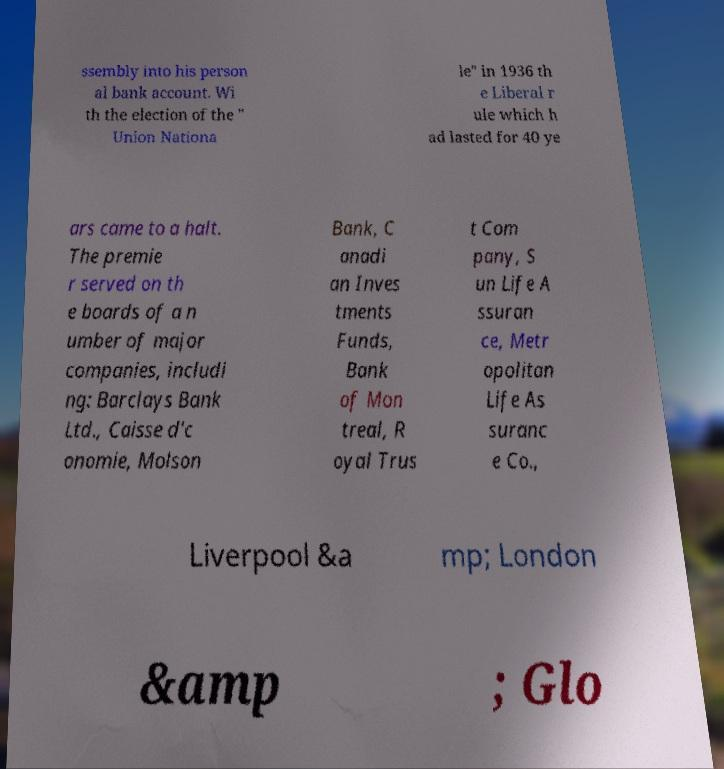Please read and relay the text visible in this image. What does it say? ssembly into his person al bank account. Wi th the election of the " Union Nationa le" in 1936 th e Liberal r ule which h ad lasted for 40 ye ars came to a halt. The premie r served on th e boards of a n umber of major companies, includi ng: Barclays Bank Ltd., Caisse d'c onomie, Molson Bank, C anadi an Inves tments Funds, Bank of Mon treal, R oyal Trus t Com pany, S un Life A ssuran ce, Metr opolitan Life As suranc e Co., Liverpool &a mp; London &amp ; Glo 